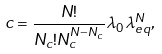Convert formula to latex. <formula><loc_0><loc_0><loc_500><loc_500>c = \frac { N ! } { N _ { c } ! N _ { c } ^ { N - N _ { c } } } \lambda _ { 0 } \lambda _ { e q } ^ { N } ,</formula> 